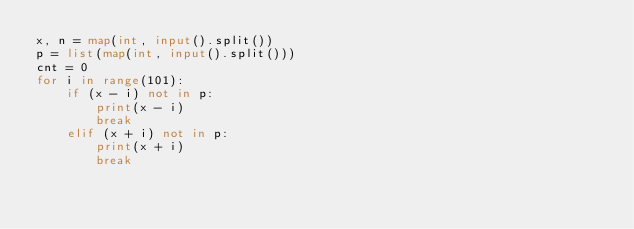Convert code to text. <code><loc_0><loc_0><loc_500><loc_500><_Python_>x, n = map(int, input().split())
p = list(map(int, input().split()))
cnt = 0
for i in range(101):
    if (x - i) not in p:
        print(x - i)
        break
    elif (x + i) not in p:
        print(x + i)
        break</code> 